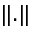<formula> <loc_0><loc_0><loc_500><loc_500>\| . \|</formula> 